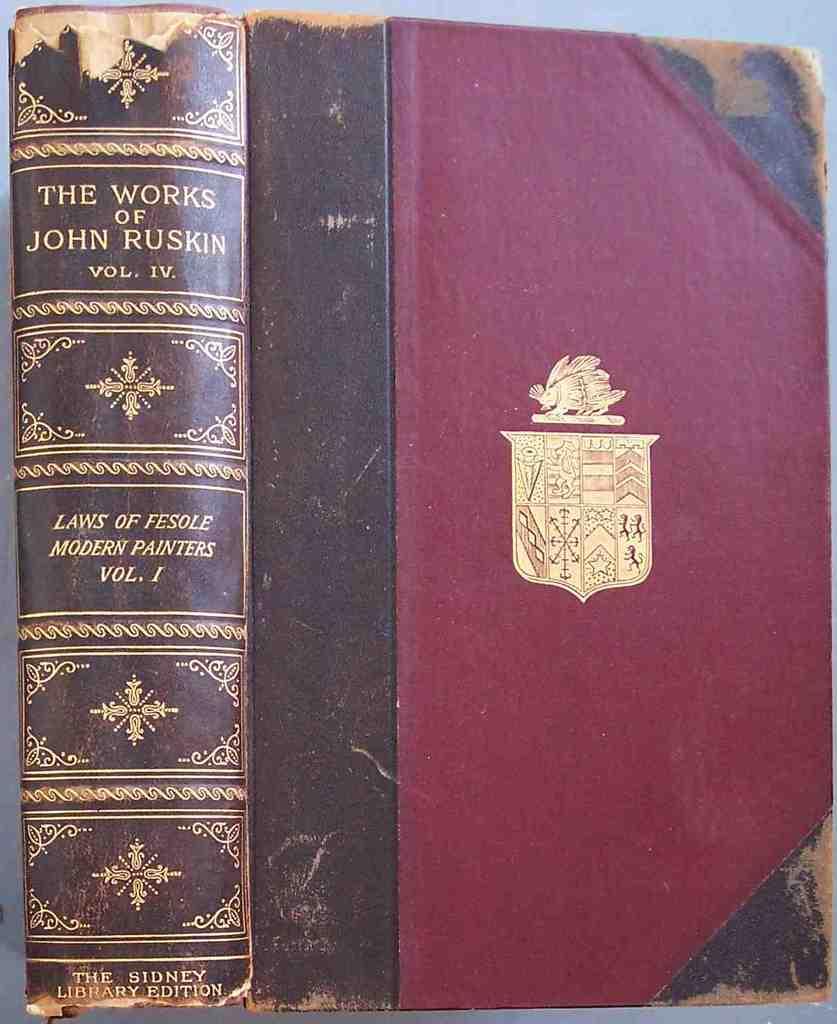Which volume is this book?
Keep it short and to the point. Iv. These are the works of who?
Offer a terse response. John ruskin. 